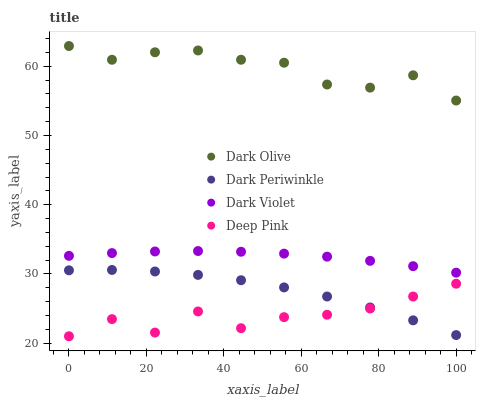Does Deep Pink have the minimum area under the curve?
Answer yes or no. Yes. Does Dark Olive have the maximum area under the curve?
Answer yes or no. Yes. Does Dark Periwinkle have the minimum area under the curve?
Answer yes or no. No. Does Dark Periwinkle have the maximum area under the curve?
Answer yes or no. No. Is Dark Violet the smoothest?
Answer yes or no. Yes. Is Deep Pink the roughest?
Answer yes or no. Yes. Is Dark Periwinkle the smoothest?
Answer yes or no. No. Is Dark Periwinkle the roughest?
Answer yes or no. No. Does Deep Pink have the lowest value?
Answer yes or no. Yes. Does Dark Periwinkle have the lowest value?
Answer yes or no. No. Does Dark Olive have the highest value?
Answer yes or no. Yes. Does Dark Periwinkle have the highest value?
Answer yes or no. No. Is Deep Pink less than Dark Violet?
Answer yes or no. Yes. Is Dark Olive greater than Dark Violet?
Answer yes or no. Yes. Does Dark Periwinkle intersect Deep Pink?
Answer yes or no. Yes. Is Dark Periwinkle less than Deep Pink?
Answer yes or no. No. Is Dark Periwinkle greater than Deep Pink?
Answer yes or no. No. Does Deep Pink intersect Dark Violet?
Answer yes or no. No. 